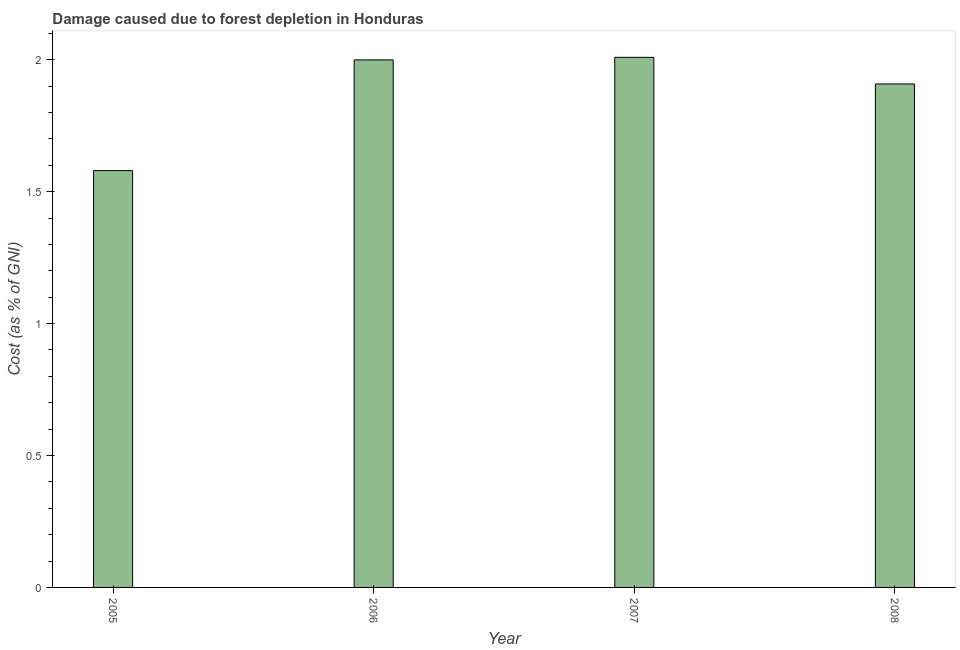Does the graph contain grids?
Give a very brief answer. No. What is the title of the graph?
Your response must be concise. Damage caused due to forest depletion in Honduras. What is the label or title of the Y-axis?
Your answer should be compact. Cost (as % of GNI). What is the damage caused due to forest depletion in 2007?
Give a very brief answer. 2.01. Across all years, what is the maximum damage caused due to forest depletion?
Your response must be concise. 2.01. Across all years, what is the minimum damage caused due to forest depletion?
Keep it short and to the point. 1.58. What is the sum of the damage caused due to forest depletion?
Your answer should be compact. 7.5. What is the difference between the damage caused due to forest depletion in 2006 and 2008?
Your answer should be compact. 0.09. What is the average damage caused due to forest depletion per year?
Offer a terse response. 1.87. What is the median damage caused due to forest depletion?
Your response must be concise. 1.95. Is the difference between the damage caused due to forest depletion in 2006 and 2008 greater than the difference between any two years?
Keep it short and to the point. No. Is the sum of the damage caused due to forest depletion in 2006 and 2008 greater than the maximum damage caused due to forest depletion across all years?
Provide a short and direct response. Yes. What is the difference between the highest and the lowest damage caused due to forest depletion?
Offer a very short reply. 0.43. Are all the bars in the graph horizontal?
Provide a short and direct response. No. How many years are there in the graph?
Offer a terse response. 4. Are the values on the major ticks of Y-axis written in scientific E-notation?
Your answer should be compact. No. What is the Cost (as % of GNI) in 2005?
Make the answer very short. 1.58. What is the Cost (as % of GNI) of 2006?
Keep it short and to the point. 2. What is the Cost (as % of GNI) of 2007?
Give a very brief answer. 2.01. What is the Cost (as % of GNI) of 2008?
Provide a short and direct response. 1.91. What is the difference between the Cost (as % of GNI) in 2005 and 2006?
Give a very brief answer. -0.42. What is the difference between the Cost (as % of GNI) in 2005 and 2007?
Ensure brevity in your answer.  -0.43. What is the difference between the Cost (as % of GNI) in 2005 and 2008?
Keep it short and to the point. -0.33. What is the difference between the Cost (as % of GNI) in 2006 and 2007?
Keep it short and to the point. -0.01. What is the difference between the Cost (as % of GNI) in 2006 and 2008?
Offer a very short reply. 0.09. What is the difference between the Cost (as % of GNI) in 2007 and 2008?
Make the answer very short. 0.1. What is the ratio of the Cost (as % of GNI) in 2005 to that in 2006?
Your answer should be very brief. 0.79. What is the ratio of the Cost (as % of GNI) in 2005 to that in 2007?
Offer a terse response. 0.79. What is the ratio of the Cost (as % of GNI) in 2005 to that in 2008?
Give a very brief answer. 0.83. What is the ratio of the Cost (as % of GNI) in 2006 to that in 2007?
Offer a very short reply. 0.99. What is the ratio of the Cost (as % of GNI) in 2006 to that in 2008?
Provide a succinct answer. 1.05. What is the ratio of the Cost (as % of GNI) in 2007 to that in 2008?
Keep it short and to the point. 1.05. 